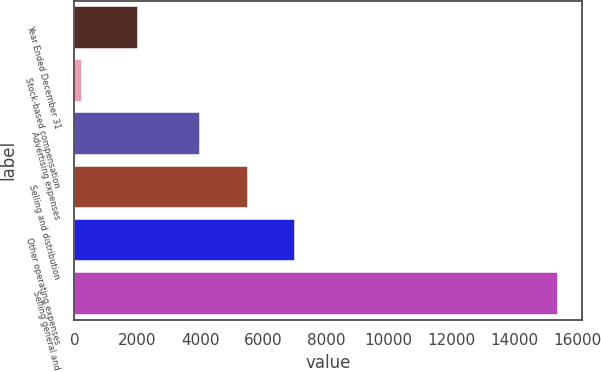Convert chart. <chart><loc_0><loc_0><loc_500><loc_500><bar_chart><fcel>Year Ended December 31<fcel>Stock-based compensation<fcel>Advertising expenses<fcel>Selling and distribution<fcel>Other operating expenses<fcel>Selling general and<nl><fcel>2016<fcel>258<fcel>4004<fcel>5515.2<fcel>7026.4<fcel>15370<nl></chart> 